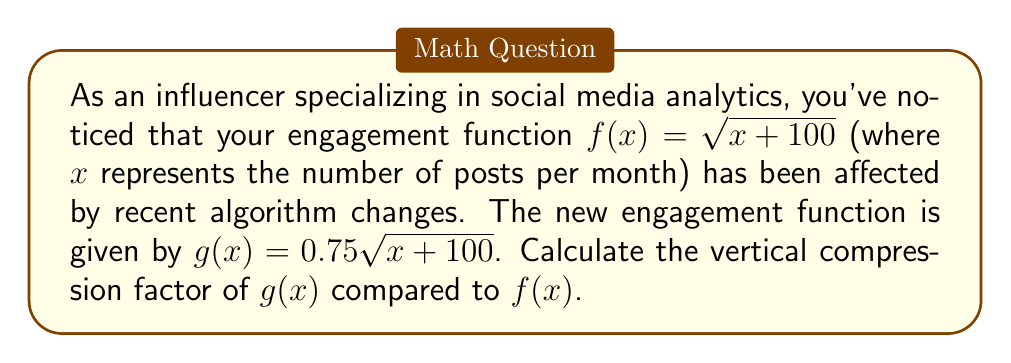Show me your answer to this math problem. To determine the vertical compression factor, we need to compare the new function $g(x)$ to the original function $f(x)$:

1. Original function: $f(x) = \sqrt{x + 100}$
2. New function: $g(x) = 0.75\sqrt{x + 100}$

3. We can rewrite $g(x)$ in terms of $f(x)$:
   $g(x) = 0.75\sqrt{x + 100} = 0.75 \cdot f(x)$

4. The general form of a vertical compression is:
   $g(x) = a \cdot f(x)$, where $0 < a < 1$

5. In this case, $a = 0.75$

6. The vertical compression factor is the reciprocal of $a$:
   Compression factor = $\frac{1}{a} = \frac{1}{0.75} = \frac{4}{3}$

Therefore, the vertical compression factor is $\frac{4}{3}$ or 1.33 (rounded to two decimal places).
Answer: $\frac{4}{3}$ 